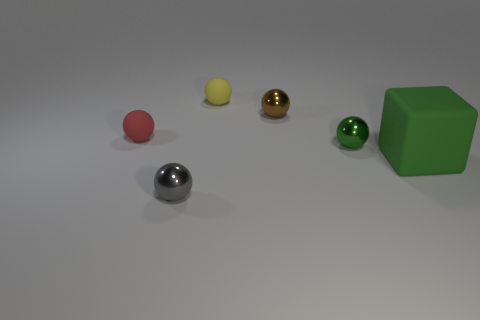There is a metal ball that is the same color as the matte cube; what is its size?
Your answer should be very brief. Small. What is the material of the other object that is the same color as the big matte object?
Make the answer very short. Metal. The large green rubber object is what shape?
Keep it short and to the point. Cube. What is the color of the tiny matte ball that is on the left side of the metal ball left of the brown sphere?
Provide a short and direct response. Red. How big is the rubber ball that is on the right side of the small gray thing?
Make the answer very short. Small. Is there a green block that has the same material as the brown sphere?
Provide a succinct answer. No. What number of red things are the same shape as the yellow thing?
Your answer should be compact. 1. There is a big thing that is behind the metal thing that is in front of the green thing that is to the left of the big green rubber block; what is its shape?
Your response must be concise. Cube. What material is the thing that is in front of the tiny green metallic ball and behind the gray thing?
Make the answer very short. Rubber. There is a shiny object that is behind the red object; does it have the same size as the gray object?
Give a very brief answer. Yes. 